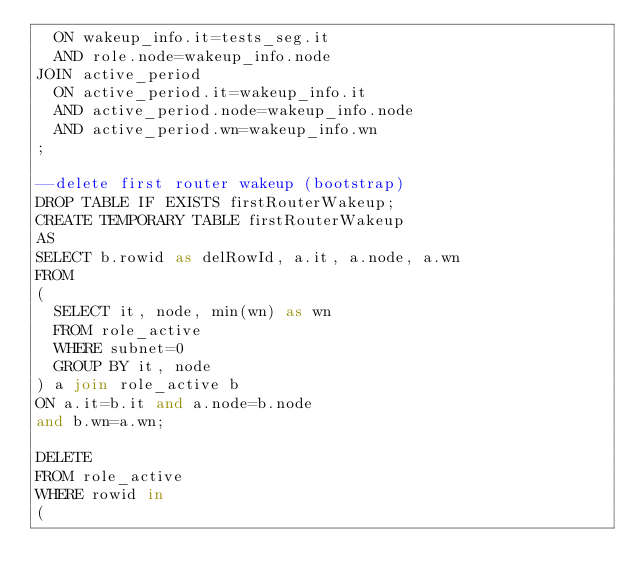<code> <loc_0><loc_0><loc_500><loc_500><_SQL_>  ON wakeup_info.it=tests_seg.it
  AND role.node=wakeup_info.node
JOIN active_period
  ON active_period.it=wakeup_info.it
  AND active_period.node=wakeup_info.node
  AND active_period.wn=wakeup_info.wn
;

--delete first router wakeup (bootstrap) 
DROP TABLE IF EXISTS firstRouterWakeup;
CREATE TEMPORARY TABLE firstRouterWakeup
AS 
SELECT b.rowid as delRowId, a.it, a.node, a.wn
FROM 
( 
  SELECT it, node, min(wn) as wn
  FROM role_active
  WHERE subnet=0
  GROUP BY it, node
) a join role_active b
ON a.it=b.it and a.node=b.node
and b.wn=a.wn;

DELETE 
FROM role_active
WHERE rowid in
(</code> 